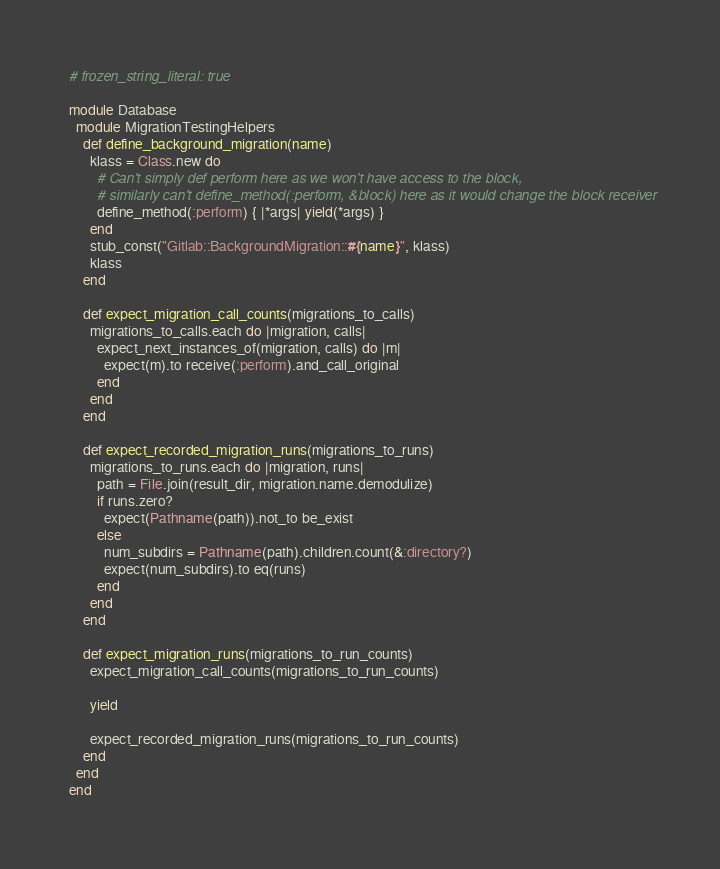<code> <loc_0><loc_0><loc_500><loc_500><_Ruby_># frozen_string_literal: true

module Database
  module MigrationTestingHelpers
    def define_background_migration(name)
      klass = Class.new do
        # Can't simply def perform here as we won't have access to the block,
        # similarly can't define_method(:perform, &block) here as it would change the block receiver
        define_method(:perform) { |*args| yield(*args) }
      end
      stub_const("Gitlab::BackgroundMigration::#{name}", klass)
      klass
    end

    def expect_migration_call_counts(migrations_to_calls)
      migrations_to_calls.each do |migration, calls|
        expect_next_instances_of(migration, calls) do |m|
          expect(m).to receive(:perform).and_call_original
        end
      end
    end

    def expect_recorded_migration_runs(migrations_to_runs)
      migrations_to_runs.each do |migration, runs|
        path = File.join(result_dir, migration.name.demodulize)
        if runs.zero?
          expect(Pathname(path)).not_to be_exist
        else
          num_subdirs = Pathname(path).children.count(&:directory?)
          expect(num_subdirs).to eq(runs)
        end
      end
    end

    def expect_migration_runs(migrations_to_run_counts)
      expect_migration_call_counts(migrations_to_run_counts)

      yield

      expect_recorded_migration_runs(migrations_to_run_counts)
    end
  end
end
</code> 